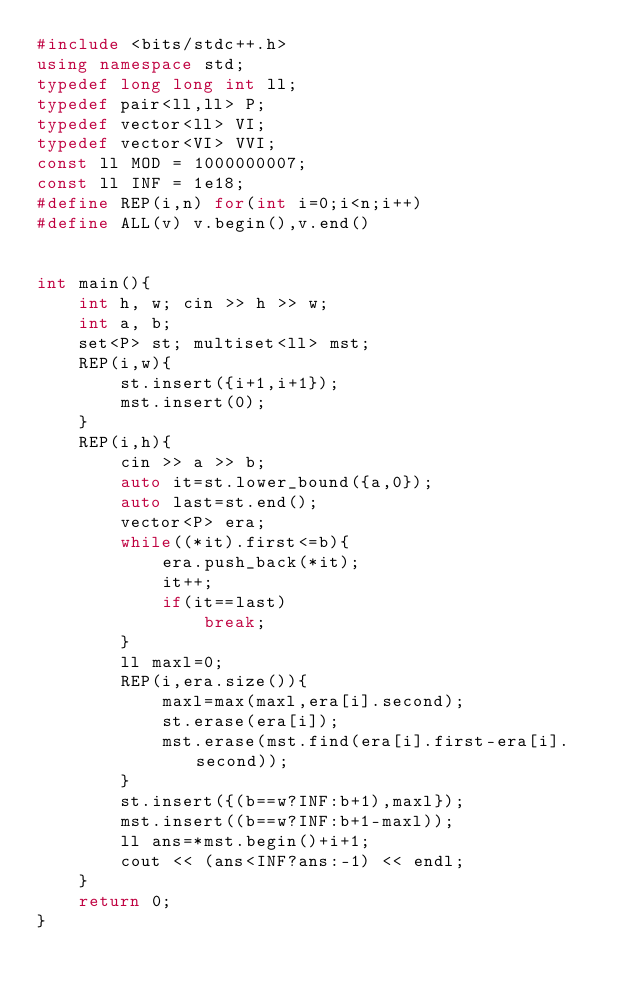<code> <loc_0><loc_0><loc_500><loc_500><_C++_>#include <bits/stdc++.h>
using namespace std;
typedef long long int ll;
typedef pair<ll,ll> P;
typedef vector<ll> VI;
typedef vector<VI> VVI;
const ll MOD = 1000000007;
const ll INF = 1e18;
#define REP(i,n) for(int i=0;i<n;i++)
#define ALL(v) v.begin(),v.end()


int main(){
	int h, w; cin >> h >> w;
	int a, b;
	set<P> st; multiset<ll> mst;
	REP(i,w){
		st.insert({i+1,i+1});
		mst.insert(0);
	}
	REP(i,h){
		cin >> a >> b;
		auto it=st.lower_bound({a,0});
		auto last=st.end();
		vector<P> era;
		while((*it).first<=b){
			era.push_back(*it);
			it++;
			if(it==last)
				break;
		}
		ll maxl=0;
		REP(i,era.size()){
			maxl=max(maxl,era[i].second);
			st.erase(era[i]);
			mst.erase(mst.find(era[i].first-era[i].second));
		}
		st.insert({(b==w?INF:b+1),maxl});
		mst.insert((b==w?INF:b+1-maxl));
		ll ans=*mst.begin()+i+1;
		cout << (ans<INF?ans:-1) << endl;
	}
	return 0;
}</code> 